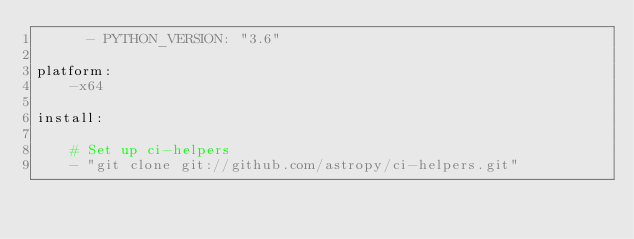Convert code to text. <code><loc_0><loc_0><loc_500><loc_500><_YAML_>      - PYTHON_VERSION: "3.6"

platform:
    -x64

install:

    # Set up ci-helpers
    - "git clone git://github.com/astropy/ci-helpers.git"</code> 